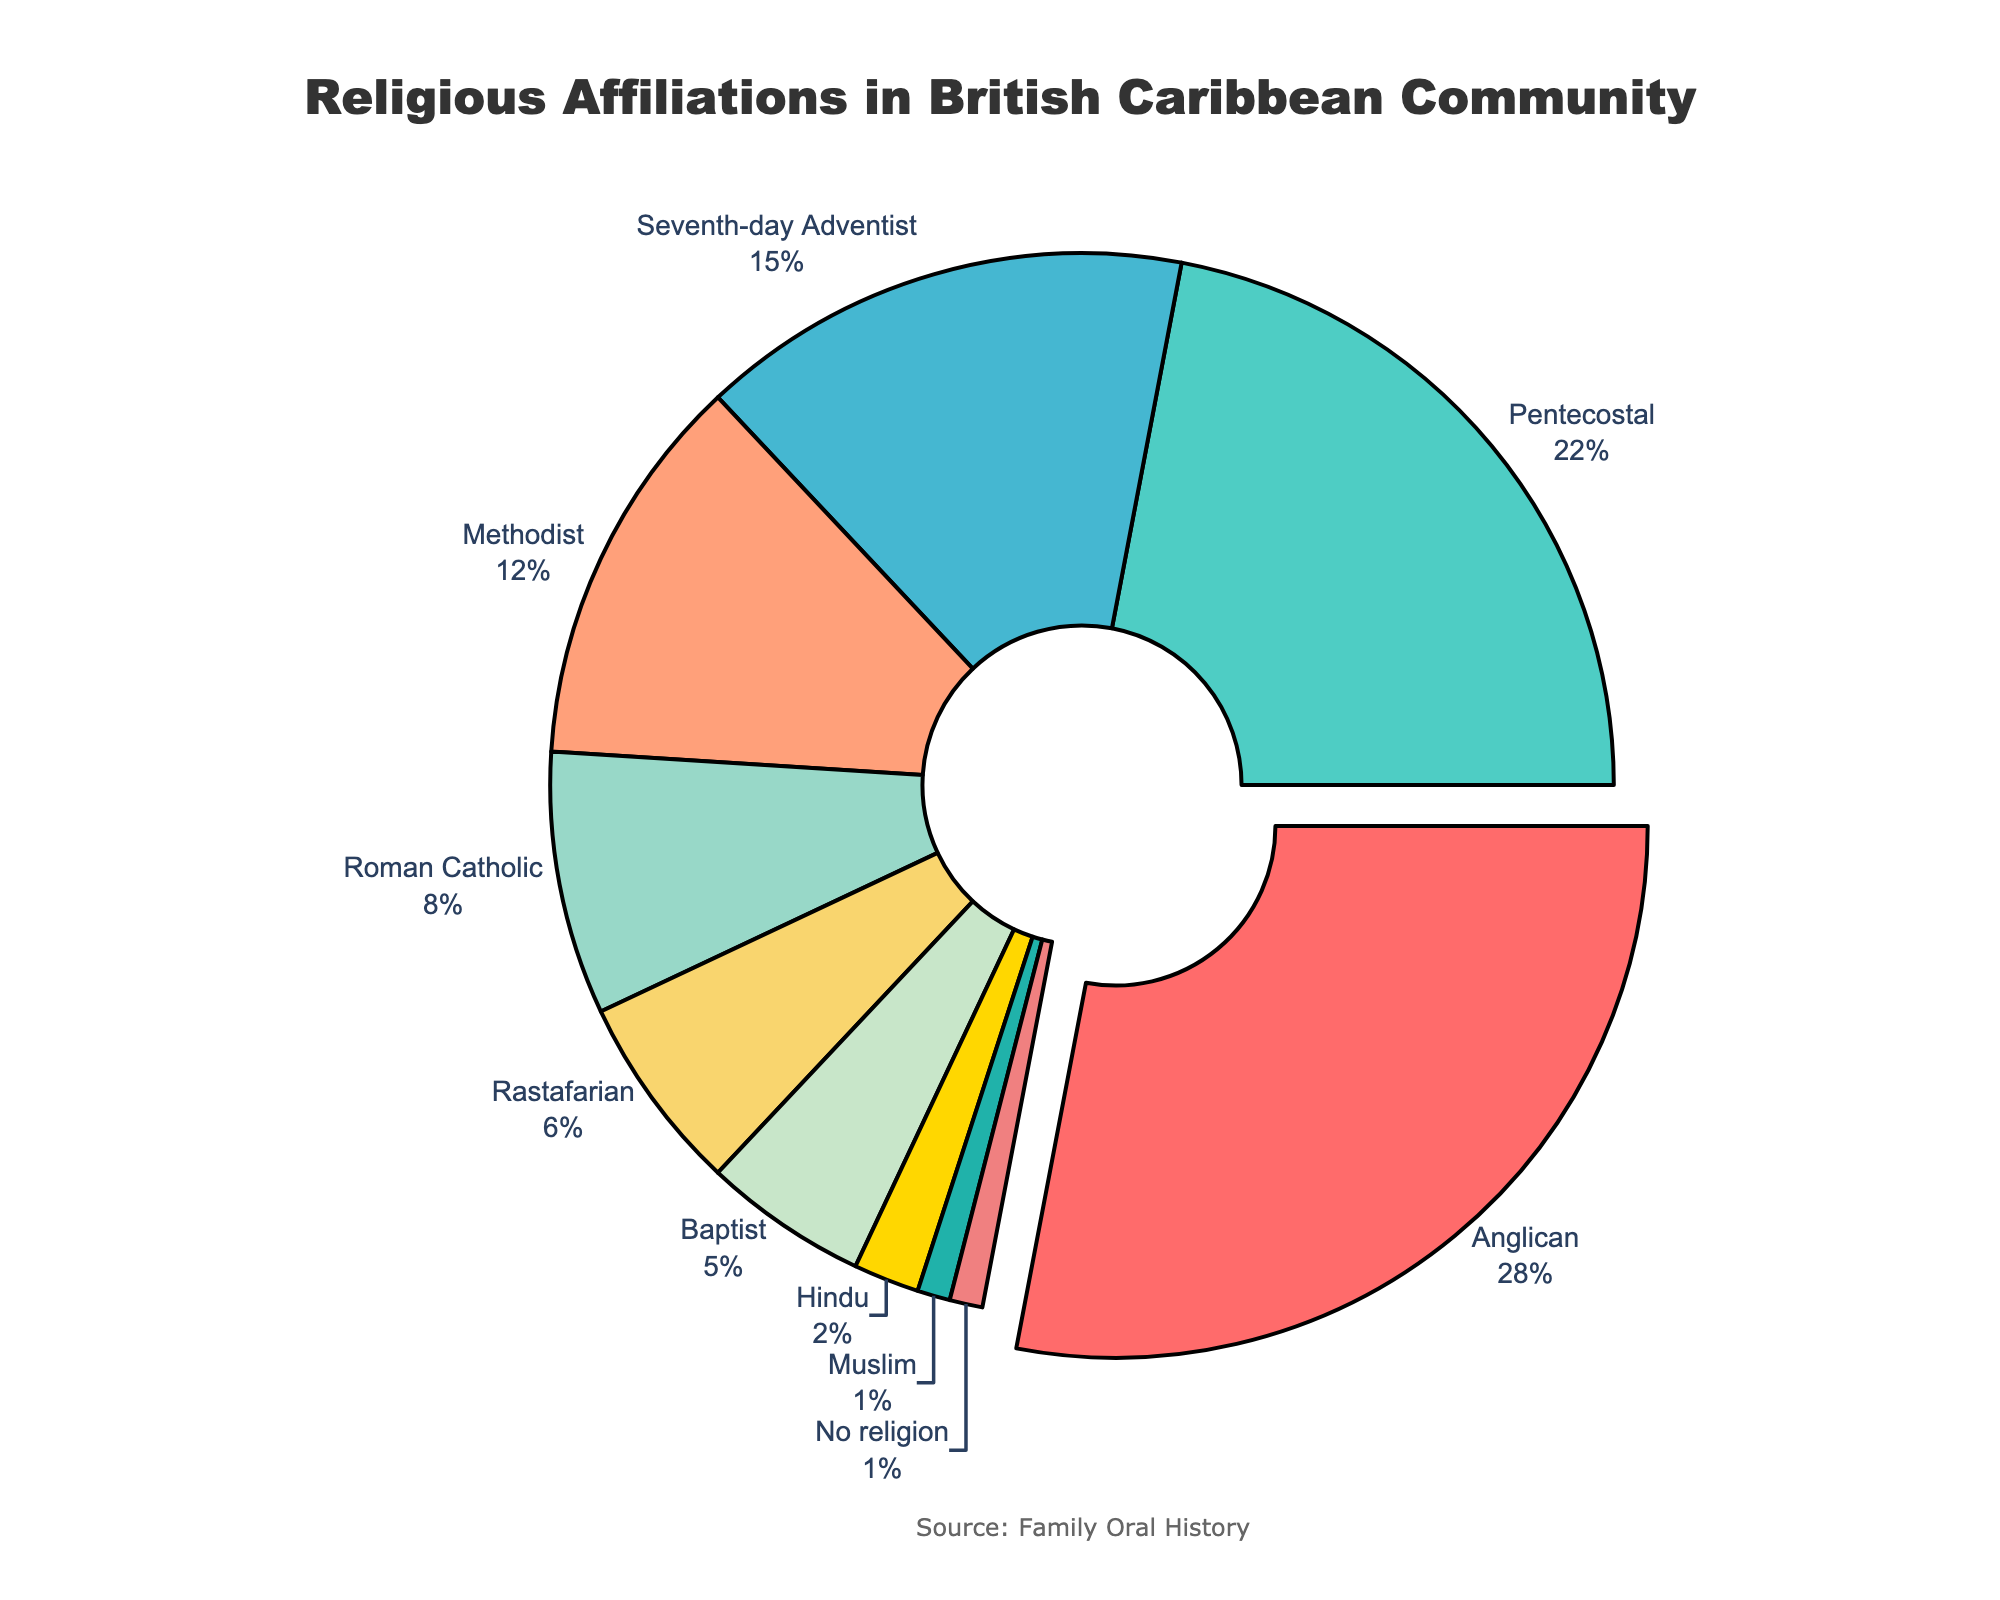What is the most common religious affiliation within the British Caribbean community? The figure highlights the religion with the highest percentage by slightly pulling its section out from the rest of the pie chart. From the visual information, the 'Anglican' section is pulled out and shows a percentage of 28%. Therefore, Anglican is the most common religion.
Answer: Anglican Which religious affiliation has the smallest percentage in the community? By examining the pie chart, the smallest section represents the religion with the smallest percentage. The 'Muslim' and 'No religion' sections are the smallest, both showing 1%.
Answer: Muslim and No religion What is the combined percentage of Pentecostal and Methodist followers? From the pie chart, Pentecostal has a percentage of 22%, and Methodist has 12%. Adding these, the combined percentage is 22% + 12% = 34%.
Answer: 34% Which is more prevalent in the community, Baptists or Hindus? By comparing the pie chart sections for Baptist and Hindu affiliations, the percentage for Baptists is 5%, whereas Hindus have 2%. Therefore, Baptists are more prevalent.
Answer: Baptists How much larger is the percentage of Seventh-day Adventists compared to Rastafarians? From the pie chart, Seventh-day Adventist has 15%, and Rastafarian has 6%. The difference is 15% - 6% = 9%.
Answer: 9% What is the average percentage of the four largest religious affiliations? The four largest affiliations are Anglican (28%), Pentecostal (22%), Seventh-day Adventist (15%), and Methodist (12%). The total is 28% + 22% + 15% + 12% = 77%. The average percentage is 77% / 4 = 19.25%.
Answer: 19.25% Which religion's section is represented by the color green? By visually examining the pie chart's color layout and matching the sections, the 'Pentecostal' section is represented by green.
Answer: Pentecostal What is the total percentage of religions aside from the five largest affiliations? The five largest affiliations cover Anglican (28%), Pentecostal (22%), Seventh-day Adventist (15%), Methodist (12%), and Roman Catholic (8%), totaling 28% + 22% + 15% + 12% + 8% = 85%. Subtracting this from 100% gives the remaining affiliations' total percentage: 100% - 85% = 15%.
Answer: 15% What is the total percentage of religious affiliations with less than 10% each? The religions with less than 10% each are Roman Catholic (8%), Rastafarian (6%), Baptist (5%), Hindu (2%), and Muslim (1%), totaling 8% + 6% + 5% + 2% + 1% = 22%.
Answer: 22% Which two religions, when combined, make up exactly 20% of the community? We examine the percentages individually: Anglican (28%), Pentecostal (22%), Seventh-day Adventist (15%), Methodist (12%), Roman Catholic (8%), Rastafarian (6%), Baptist (5%), Hindu (2%), Muslim (1%), and No religion (1%). The combination of Seventh-day Adventist (15%) and Roman Catholic (8%) and then Baptist (5%) totals 15% + 5% = 20%.
Answer: Baptist and Seventh-day Adventist 